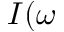Convert formula to latex. <formula><loc_0><loc_0><loc_500><loc_500>I ( \omega</formula> 